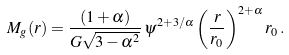<formula> <loc_0><loc_0><loc_500><loc_500>M _ { g } ( r ) = \frac { ( 1 + \alpha ) } { G \sqrt { 3 - \alpha ^ { 2 } } } \, \psi ^ { 2 + 3 / \alpha } \left ( \frac { r } { r _ { 0 } } \right ) ^ { 2 + \alpha } r _ { 0 } \, .</formula> 